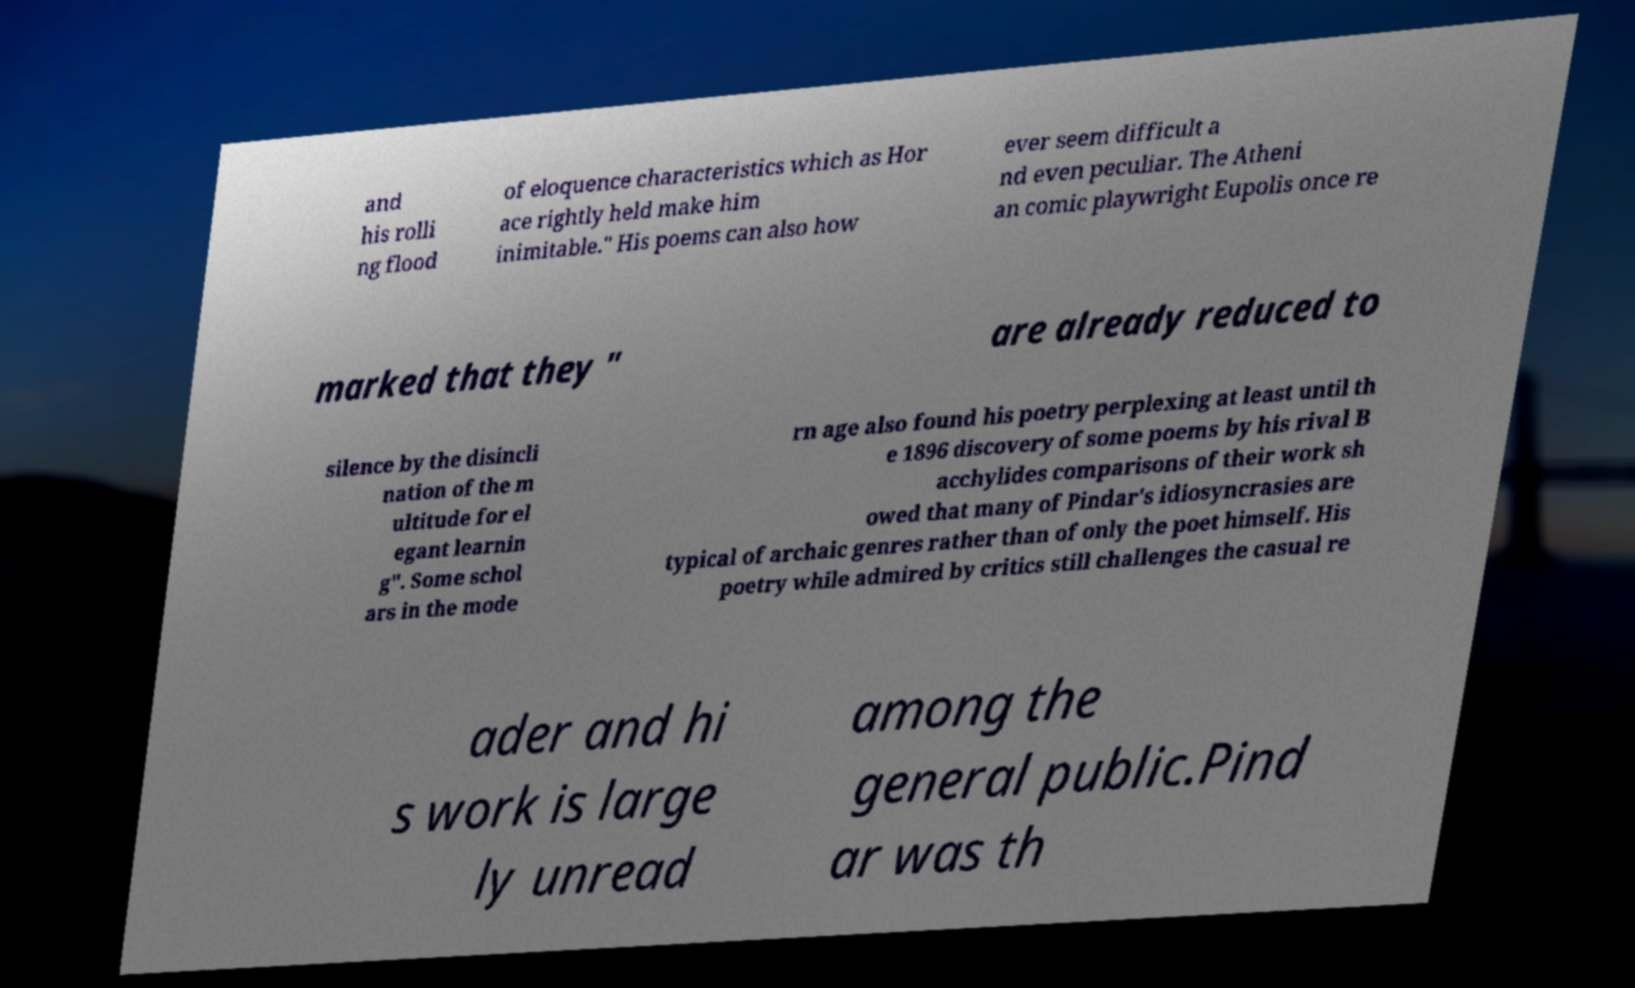Can you read and provide the text displayed in the image?This photo seems to have some interesting text. Can you extract and type it out for me? and his rolli ng flood of eloquence characteristics which as Hor ace rightly held make him inimitable." His poems can also how ever seem difficult a nd even peculiar. The Atheni an comic playwright Eupolis once re marked that they " are already reduced to silence by the disincli nation of the m ultitude for el egant learnin g". Some schol ars in the mode rn age also found his poetry perplexing at least until th e 1896 discovery of some poems by his rival B acchylides comparisons of their work sh owed that many of Pindar's idiosyncrasies are typical of archaic genres rather than of only the poet himself. His poetry while admired by critics still challenges the casual re ader and hi s work is large ly unread among the general public.Pind ar was th 